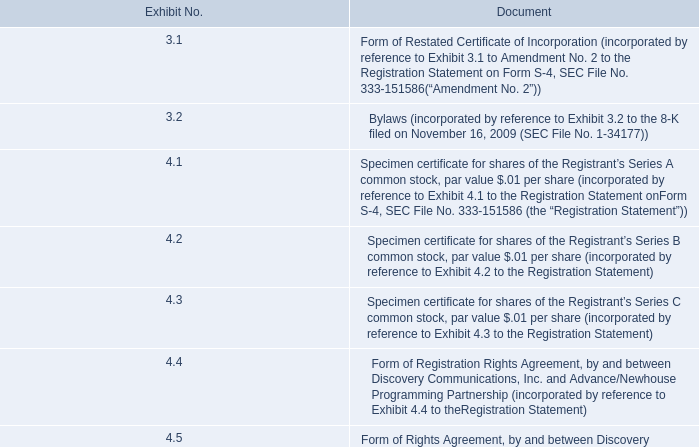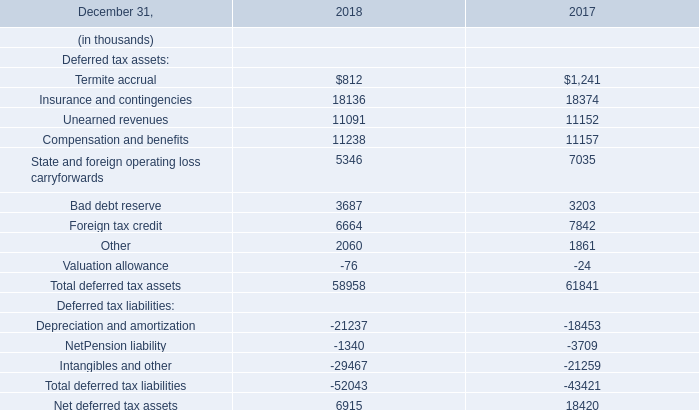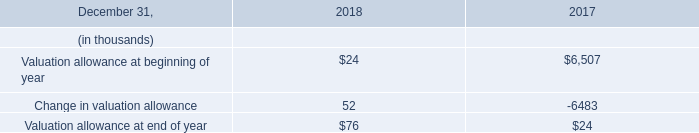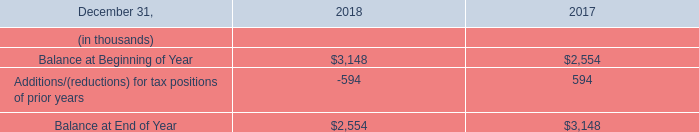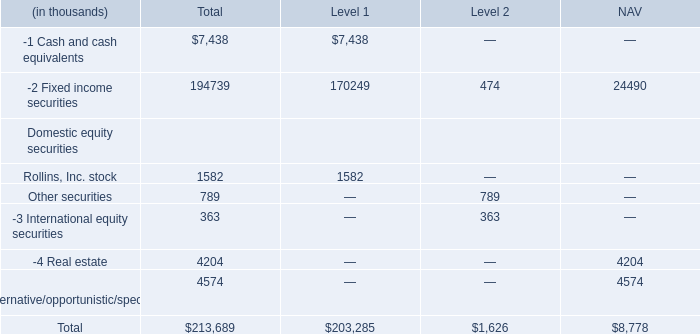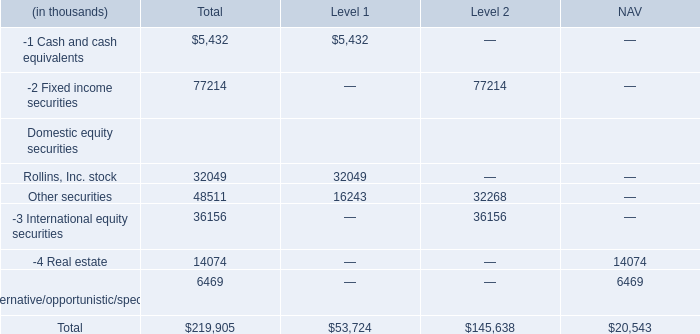As As the chart 4 shows,what is the value of Fixed income securities for Level 1? (in thousand) 
Answer: 170249. 